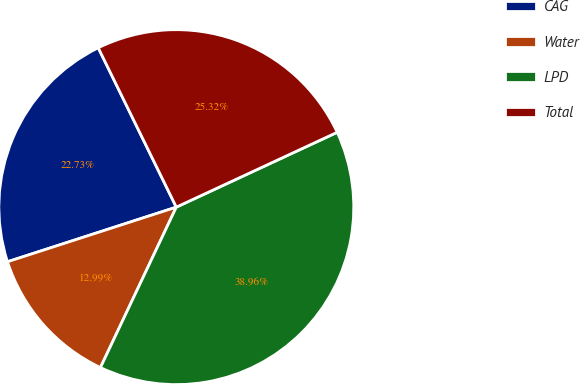Convert chart. <chart><loc_0><loc_0><loc_500><loc_500><pie_chart><fcel>CAG<fcel>Water<fcel>LPD<fcel>Total<nl><fcel>22.73%<fcel>12.99%<fcel>38.96%<fcel>25.32%<nl></chart> 